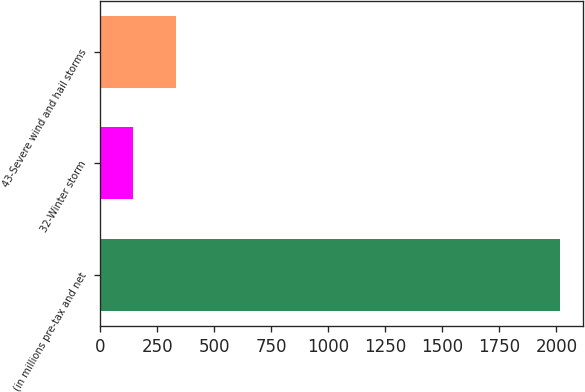<chart> <loc_0><loc_0><loc_500><loc_500><bar_chart><fcel>(in millions pre-tax and net<fcel>32-Winter storm<fcel>43-Severe wind and hail storms<nl><fcel>2014<fcel>144<fcel>331<nl></chart> 